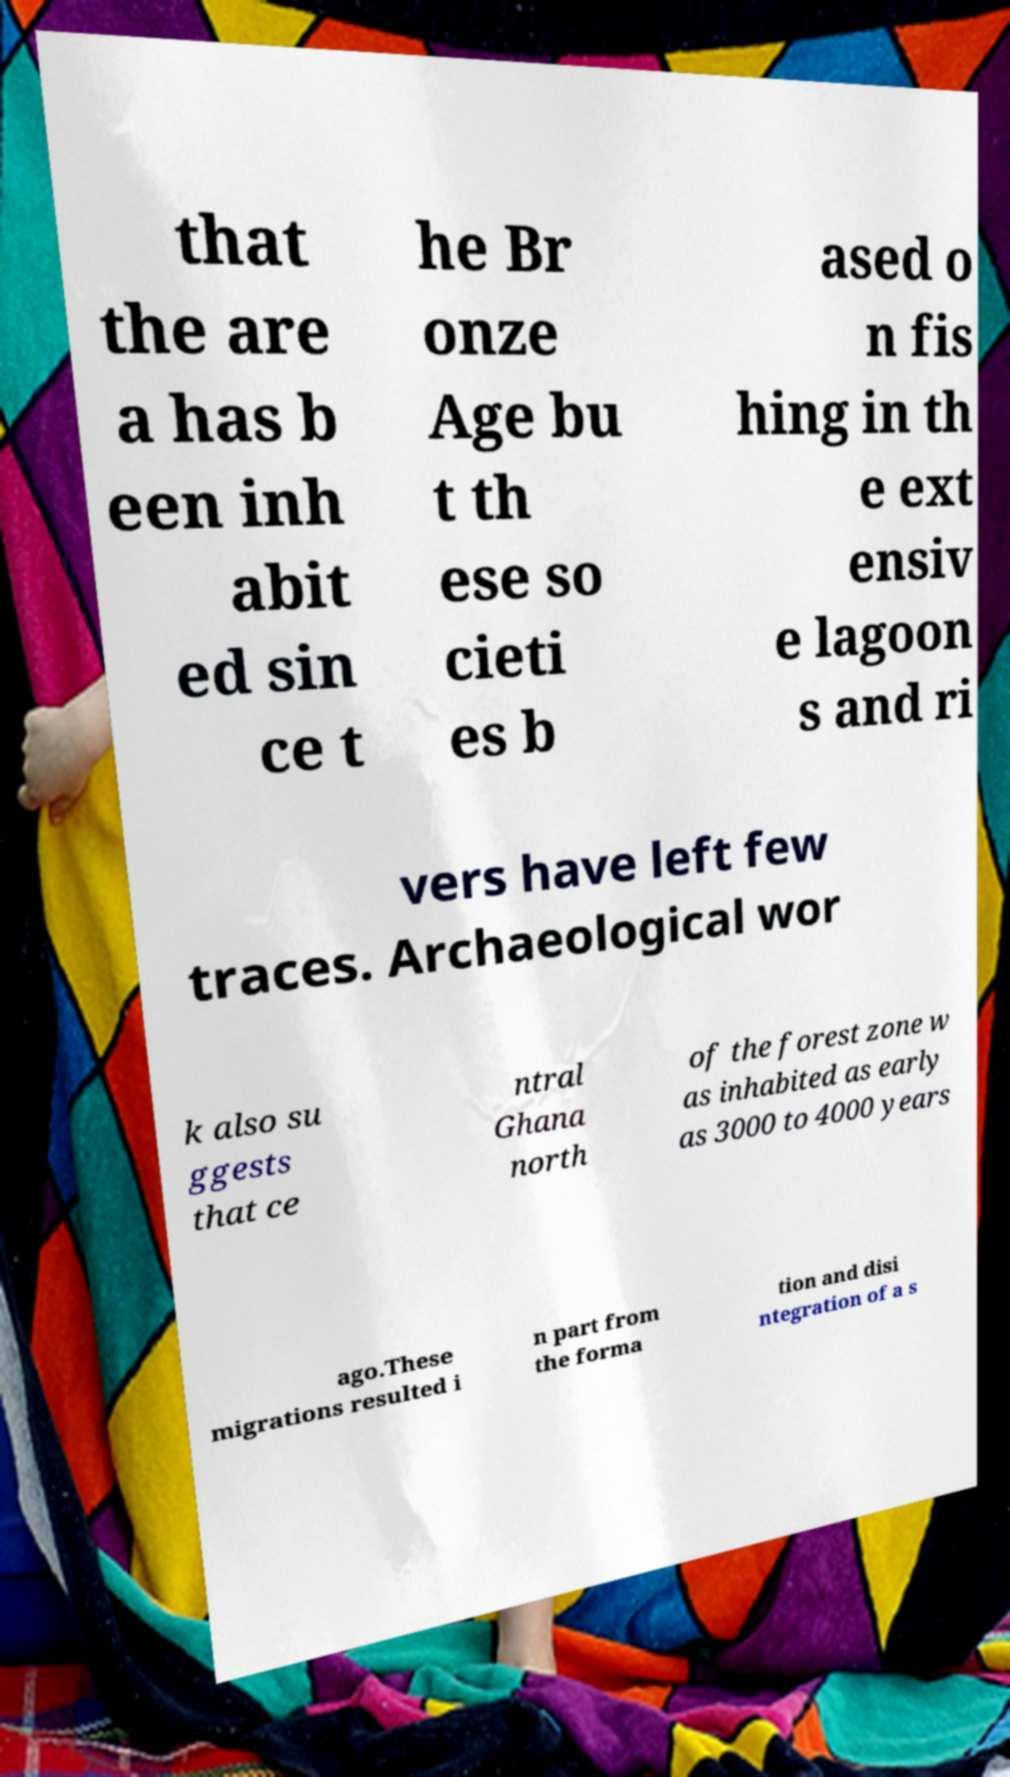Can you accurately transcribe the text from the provided image for me? that the are a has b een inh abit ed sin ce t he Br onze Age bu t th ese so cieti es b ased o n fis hing in th e ext ensiv e lagoon s and ri vers have left few traces. Archaeological wor k also su ggests that ce ntral Ghana north of the forest zone w as inhabited as early as 3000 to 4000 years ago.These migrations resulted i n part from the forma tion and disi ntegration of a s 